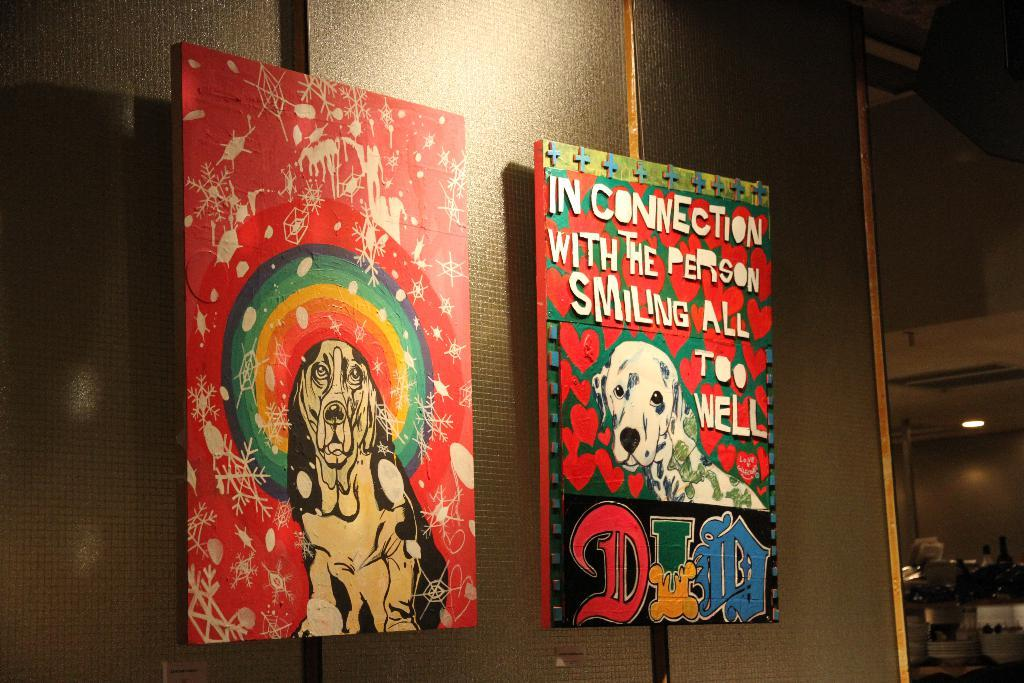How many colorful cardboards are in the image? There are 2 colorful cardboards in the image. What color are the cardboards? The cardboards are red in color. What is depicted on the cardboards? There is a picture of a dog on the cardboards. Where are the cardboards located in the image? The cardboards are hanged on the wall. What caption is written under the picture of the frog on the cardboards? There is no picture of a frog on the cardboards; it is a picture of a dog. 